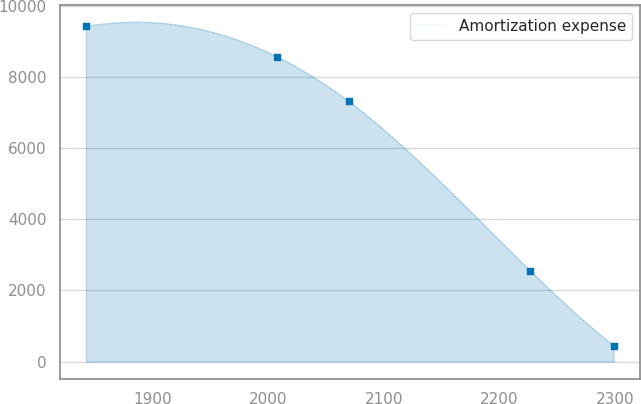Convert chart. <chart><loc_0><loc_0><loc_500><loc_500><line_chart><ecel><fcel>Amortization expense<nl><fcel>1842.07<fcel>9420.15<nl><fcel>2007.8<fcel>8558.86<nl><fcel>2069.49<fcel>7312.17<nl><fcel>2226.57<fcel>2556.17<nl><fcel>2298.99<fcel>449.04<nl></chart> 